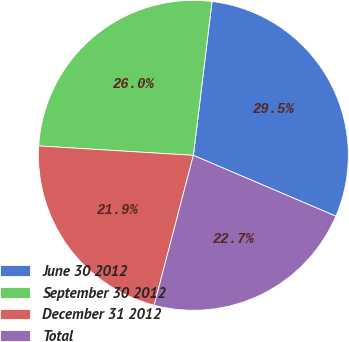Convert chart. <chart><loc_0><loc_0><loc_500><loc_500><pie_chart><fcel>June 30 2012<fcel>September 30 2012<fcel>December 31 2012<fcel>Total<nl><fcel>29.5%<fcel>25.95%<fcel>21.89%<fcel>22.65%<nl></chart> 